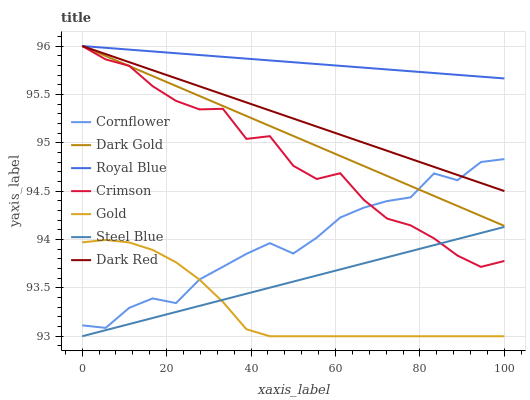Does Gold have the minimum area under the curve?
Answer yes or no. Yes. Does Royal Blue have the maximum area under the curve?
Answer yes or no. Yes. Does Dark Gold have the minimum area under the curve?
Answer yes or no. No. Does Dark Gold have the maximum area under the curve?
Answer yes or no. No. Is Royal Blue the smoothest?
Answer yes or no. Yes. Is Crimson the roughest?
Answer yes or no. Yes. Is Gold the smoothest?
Answer yes or no. No. Is Gold the roughest?
Answer yes or no. No. Does Gold have the lowest value?
Answer yes or no. Yes. Does Dark Gold have the lowest value?
Answer yes or no. No. Does Crimson have the highest value?
Answer yes or no. Yes. Does Gold have the highest value?
Answer yes or no. No. Is Gold less than Dark Red?
Answer yes or no. Yes. Is Dark Gold greater than Steel Blue?
Answer yes or no. Yes. Does Dark Gold intersect Dark Red?
Answer yes or no. Yes. Is Dark Gold less than Dark Red?
Answer yes or no. No. Is Dark Gold greater than Dark Red?
Answer yes or no. No. Does Gold intersect Dark Red?
Answer yes or no. No. 